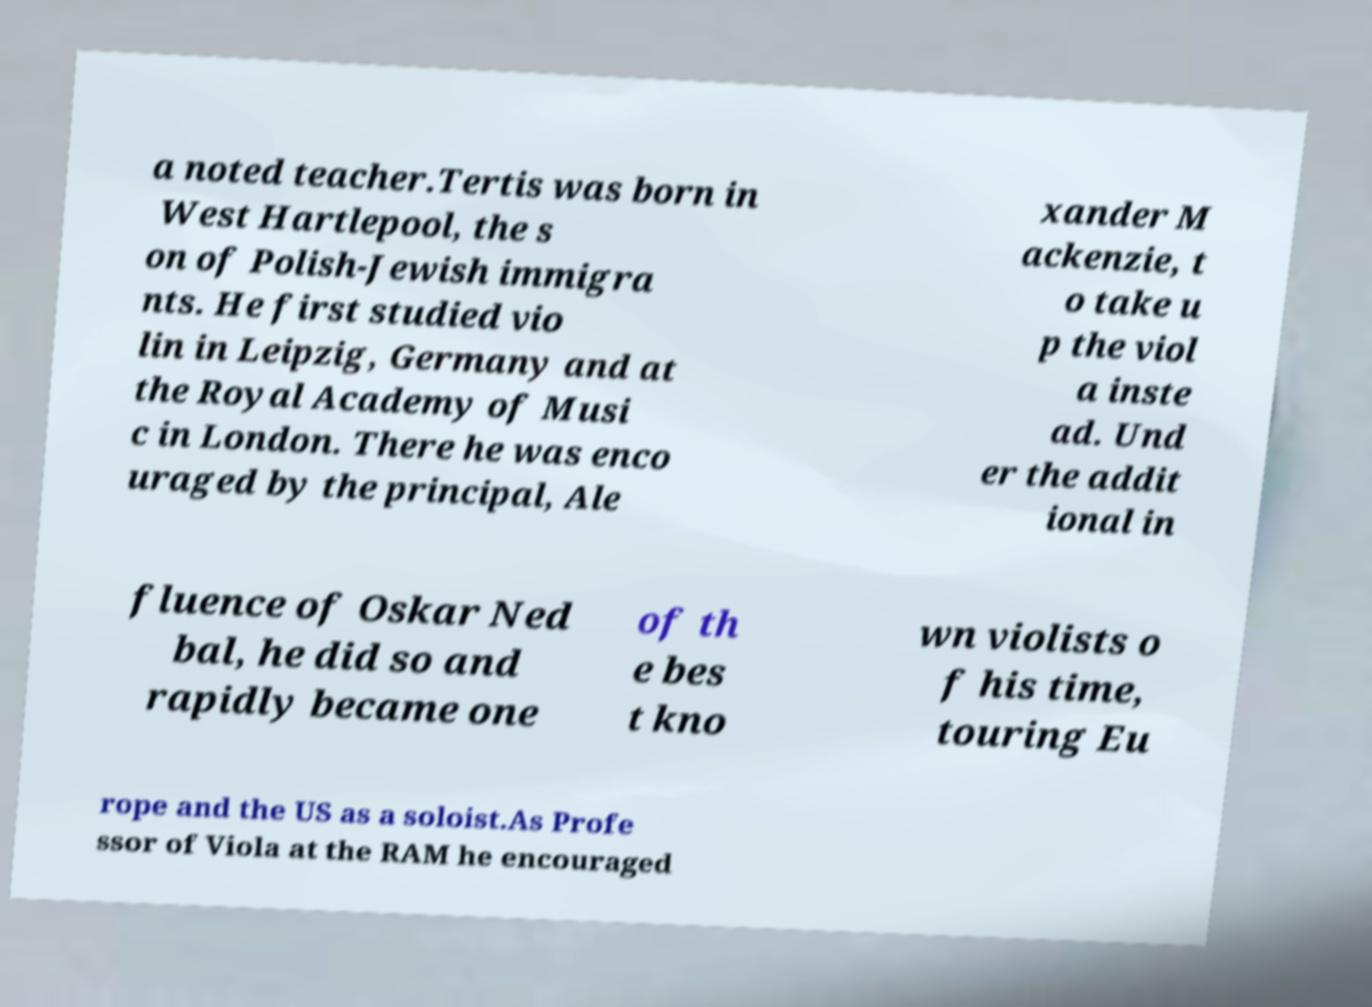I need the written content from this picture converted into text. Can you do that? a noted teacher.Tertis was born in West Hartlepool, the s on of Polish-Jewish immigra nts. He first studied vio lin in Leipzig, Germany and at the Royal Academy of Musi c in London. There he was enco uraged by the principal, Ale xander M ackenzie, t o take u p the viol a inste ad. Und er the addit ional in fluence of Oskar Ned bal, he did so and rapidly became one of th e bes t kno wn violists o f his time, touring Eu rope and the US as a soloist.As Profe ssor of Viola at the RAM he encouraged 